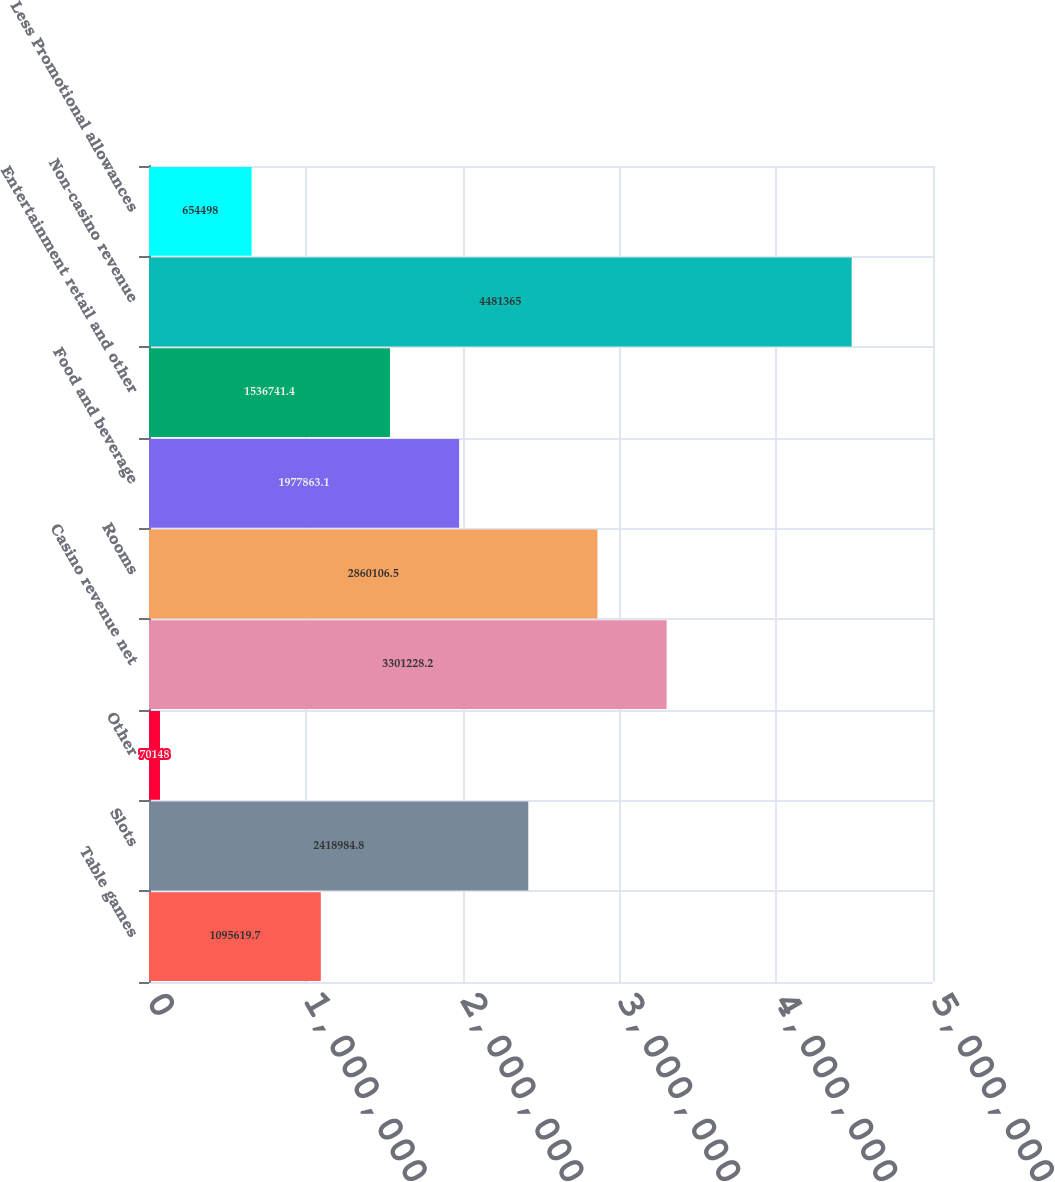<chart> <loc_0><loc_0><loc_500><loc_500><bar_chart><fcel>Table games<fcel>Slots<fcel>Other<fcel>Casino revenue net<fcel>Rooms<fcel>Food and beverage<fcel>Entertainment retail and other<fcel>Non-casino revenue<fcel>Less Promotional allowances<nl><fcel>1.09562e+06<fcel>2.41898e+06<fcel>70148<fcel>3.30123e+06<fcel>2.86011e+06<fcel>1.97786e+06<fcel>1.53674e+06<fcel>4.48136e+06<fcel>654498<nl></chart> 